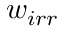<formula> <loc_0><loc_0><loc_500><loc_500>w _ { i r r }</formula> 